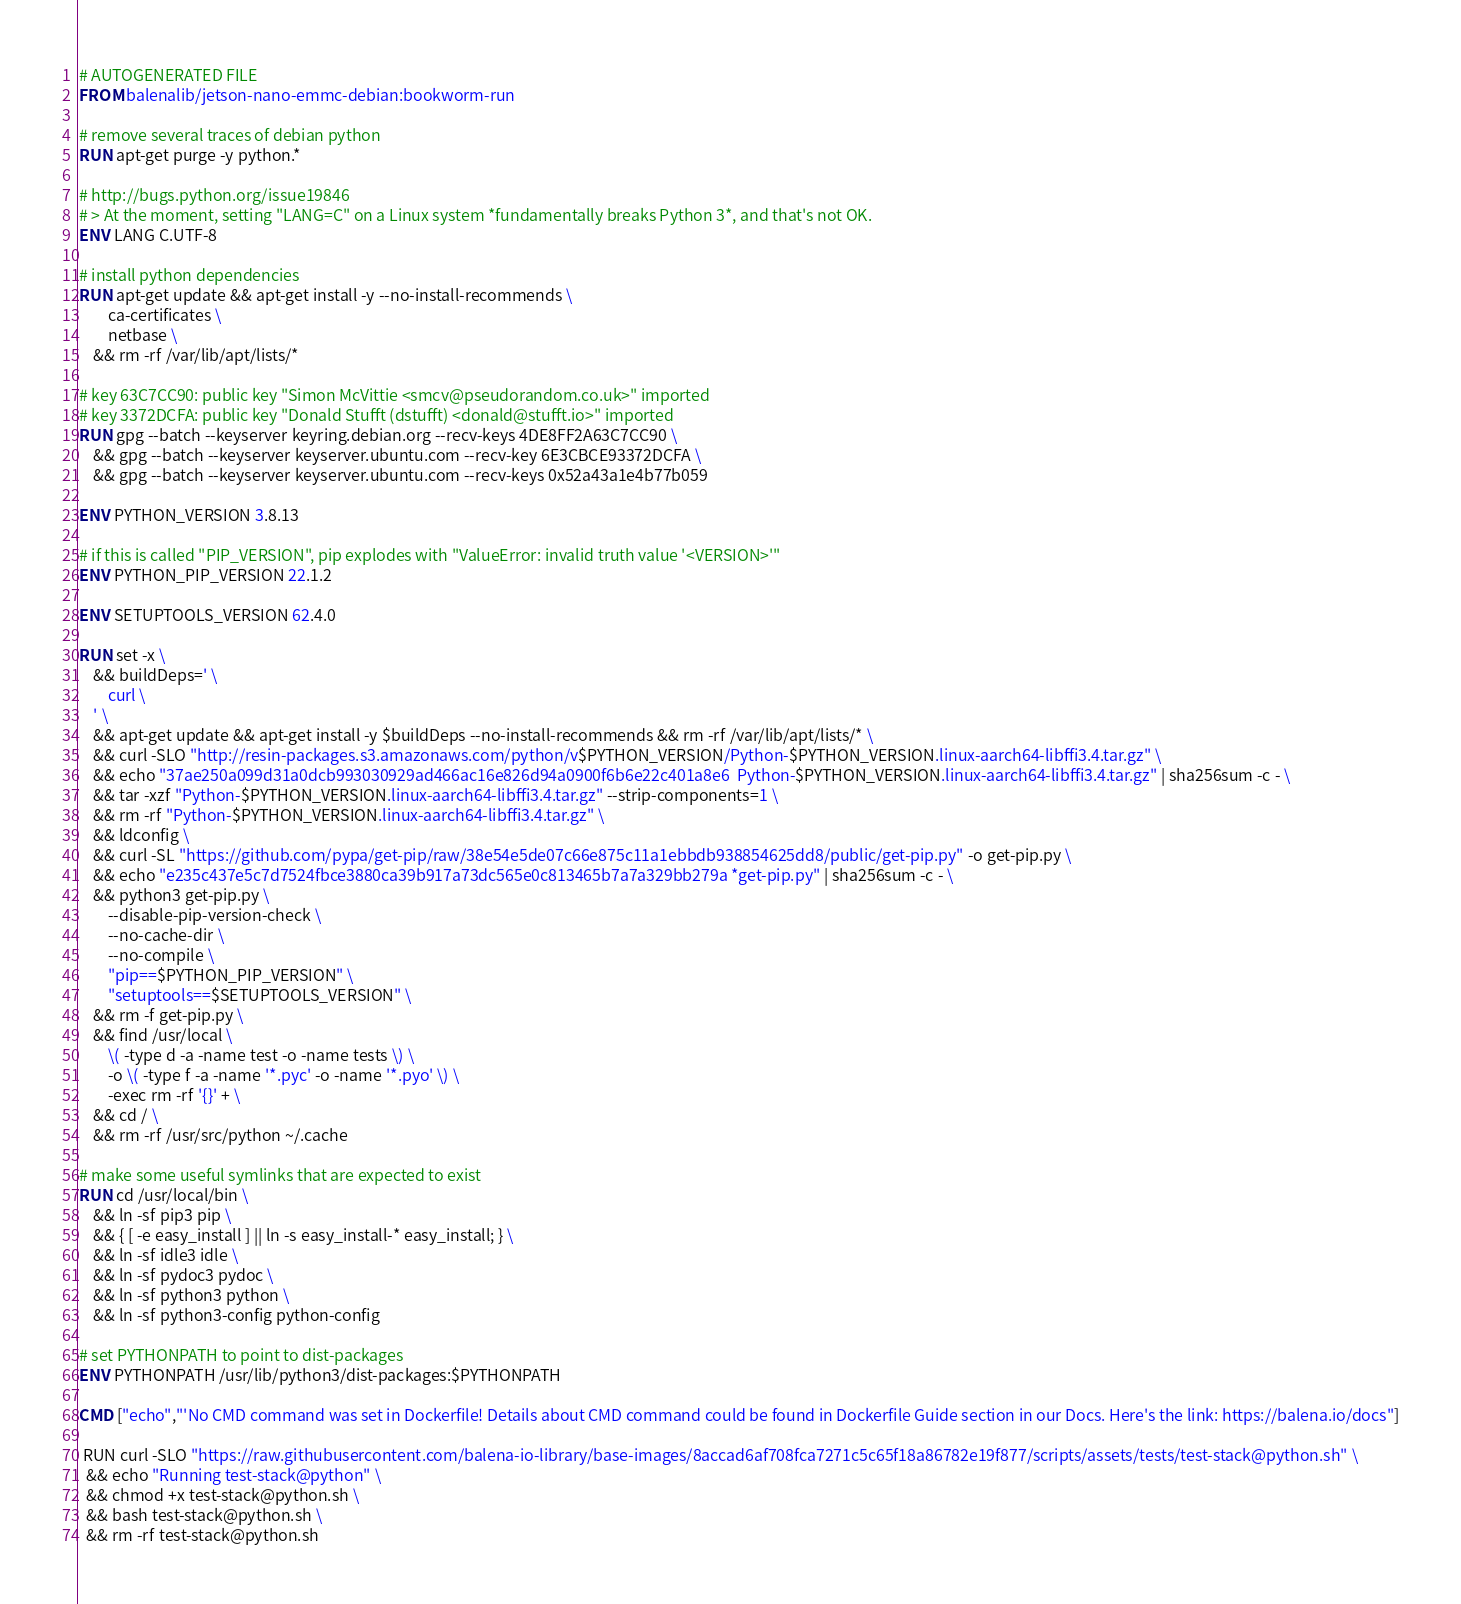<code> <loc_0><loc_0><loc_500><loc_500><_Dockerfile_># AUTOGENERATED FILE
FROM balenalib/jetson-nano-emmc-debian:bookworm-run

# remove several traces of debian python
RUN apt-get purge -y python.*

# http://bugs.python.org/issue19846
# > At the moment, setting "LANG=C" on a Linux system *fundamentally breaks Python 3*, and that's not OK.
ENV LANG C.UTF-8

# install python dependencies
RUN apt-get update && apt-get install -y --no-install-recommends \
		ca-certificates \
		netbase \
	&& rm -rf /var/lib/apt/lists/*

# key 63C7CC90: public key "Simon McVittie <smcv@pseudorandom.co.uk>" imported
# key 3372DCFA: public key "Donald Stufft (dstufft) <donald@stufft.io>" imported
RUN gpg --batch --keyserver keyring.debian.org --recv-keys 4DE8FF2A63C7CC90 \
	&& gpg --batch --keyserver keyserver.ubuntu.com --recv-key 6E3CBCE93372DCFA \
	&& gpg --batch --keyserver keyserver.ubuntu.com --recv-keys 0x52a43a1e4b77b059

ENV PYTHON_VERSION 3.8.13

# if this is called "PIP_VERSION", pip explodes with "ValueError: invalid truth value '<VERSION>'"
ENV PYTHON_PIP_VERSION 22.1.2

ENV SETUPTOOLS_VERSION 62.4.0

RUN set -x \
	&& buildDeps=' \
		curl \
	' \
	&& apt-get update && apt-get install -y $buildDeps --no-install-recommends && rm -rf /var/lib/apt/lists/* \
	&& curl -SLO "http://resin-packages.s3.amazonaws.com/python/v$PYTHON_VERSION/Python-$PYTHON_VERSION.linux-aarch64-libffi3.4.tar.gz" \
	&& echo "37ae250a099d31a0dcb993030929ad466ac16e826d94a0900f6b6e22c401a8e6  Python-$PYTHON_VERSION.linux-aarch64-libffi3.4.tar.gz" | sha256sum -c - \
	&& tar -xzf "Python-$PYTHON_VERSION.linux-aarch64-libffi3.4.tar.gz" --strip-components=1 \
	&& rm -rf "Python-$PYTHON_VERSION.linux-aarch64-libffi3.4.tar.gz" \
	&& ldconfig \
	&& curl -SL "https://github.com/pypa/get-pip/raw/38e54e5de07c66e875c11a1ebbdb938854625dd8/public/get-pip.py" -o get-pip.py \
    && echo "e235c437e5c7d7524fbce3880ca39b917a73dc565e0c813465b7a7a329bb279a *get-pip.py" | sha256sum -c - \
    && python3 get-pip.py \
        --disable-pip-version-check \
        --no-cache-dir \
        --no-compile \
        "pip==$PYTHON_PIP_VERSION" \
        "setuptools==$SETUPTOOLS_VERSION" \
	&& rm -f get-pip.py \
	&& find /usr/local \
		\( -type d -a -name test -o -name tests \) \
		-o \( -type f -a -name '*.pyc' -o -name '*.pyo' \) \
		-exec rm -rf '{}' + \
	&& cd / \
	&& rm -rf /usr/src/python ~/.cache

# make some useful symlinks that are expected to exist
RUN cd /usr/local/bin \
	&& ln -sf pip3 pip \
	&& { [ -e easy_install ] || ln -s easy_install-* easy_install; } \
	&& ln -sf idle3 idle \
	&& ln -sf pydoc3 pydoc \
	&& ln -sf python3 python \
	&& ln -sf python3-config python-config

# set PYTHONPATH to point to dist-packages
ENV PYTHONPATH /usr/lib/python3/dist-packages:$PYTHONPATH

CMD ["echo","'No CMD command was set in Dockerfile! Details about CMD command could be found in Dockerfile Guide section in our Docs. Here's the link: https://balena.io/docs"]

 RUN curl -SLO "https://raw.githubusercontent.com/balena-io-library/base-images/8accad6af708fca7271c5c65f18a86782e19f877/scripts/assets/tests/test-stack@python.sh" \
  && echo "Running test-stack@python" \
  && chmod +x test-stack@python.sh \
  && bash test-stack@python.sh \
  && rm -rf test-stack@python.sh 
</code> 